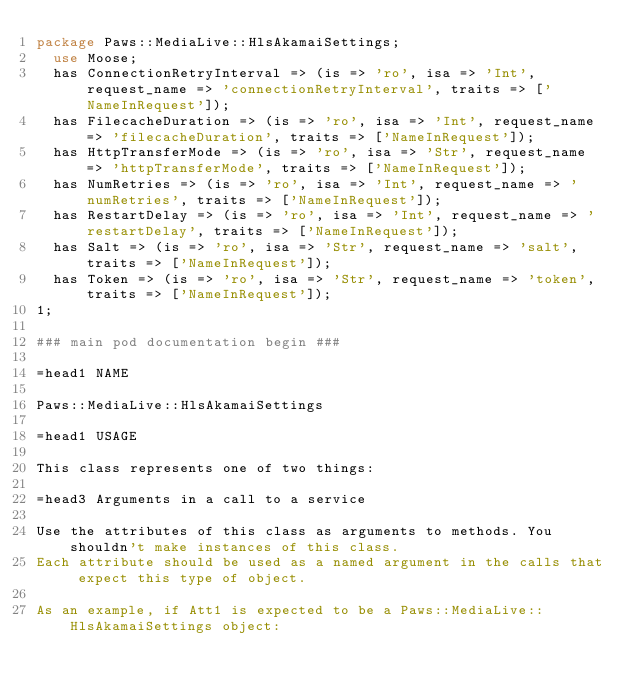Convert code to text. <code><loc_0><loc_0><loc_500><loc_500><_Perl_>package Paws::MediaLive::HlsAkamaiSettings;
  use Moose;
  has ConnectionRetryInterval => (is => 'ro', isa => 'Int', request_name => 'connectionRetryInterval', traits => ['NameInRequest']);
  has FilecacheDuration => (is => 'ro', isa => 'Int', request_name => 'filecacheDuration', traits => ['NameInRequest']);
  has HttpTransferMode => (is => 'ro', isa => 'Str', request_name => 'httpTransferMode', traits => ['NameInRequest']);
  has NumRetries => (is => 'ro', isa => 'Int', request_name => 'numRetries', traits => ['NameInRequest']);
  has RestartDelay => (is => 'ro', isa => 'Int', request_name => 'restartDelay', traits => ['NameInRequest']);
  has Salt => (is => 'ro', isa => 'Str', request_name => 'salt', traits => ['NameInRequest']);
  has Token => (is => 'ro', isa => 'Str', request_name => 'token', traits => ['NameInRequest']);
1;

### main pod documentation begin ###

=head1 NAME

Paws::MediaLive::HlsAkamaiSettings

=head1 USAGE

This class represents one of two things:

=head3 Arguments in a call to a service

Use the attributes of this class as arguments to methods. You shouldn't make instances of this class. 
Each attribute should be used as a named argument in the calls that expect this type of object.

As an example, if Att1 is expected to be a Paws::MediaLive::HlsAkamaiSettings object:
</code> 